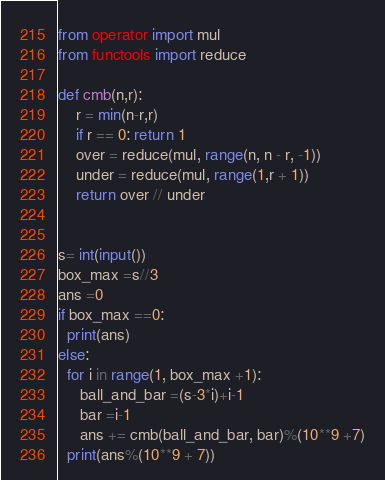<code> <loc_0><loc_0><loc_500><loc_500><_Python_>from operator import mul
from functools import reduce

def cmb(n,r):
    r = min(n-r,r)
    if r == 0: return 1
    over = reduce(mul, range(n, n - r, -1))
    under = reduce(mul, range(1,r + 1))
    return over // under


s= int(input())
box_max =s//3
ans =0
if box_max ==0:
  print(ans)
else:
  for i in range(1, box_max +1):
     ball_and_bar =(s-3*i)+i-1
     bar =i-1
     ans += cmb(ball_and_bar, bar)%(10**9 +7)
  print(ans%(10**9 + 7))</code> 